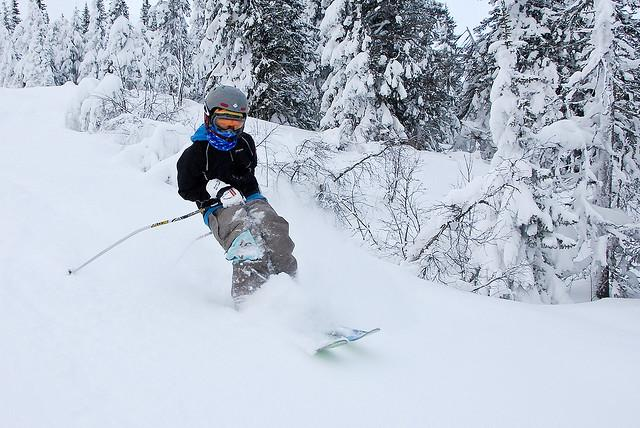Where might this child be located? mountain 